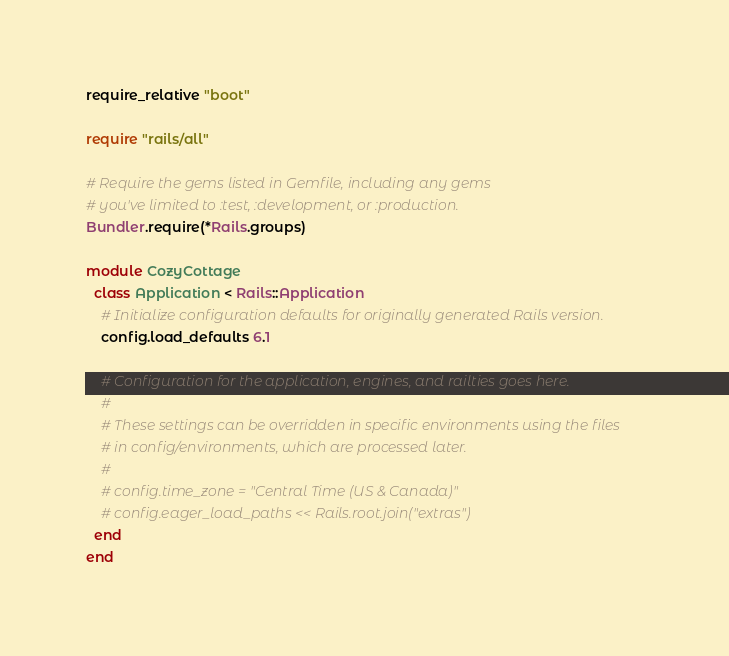Convert code to text. <code><loc_0><loc_0><loc_500><loc_500><_Ruby_>require_relative "boot"

require "rails/all"

# Require the gems listed in Gemfile, including any gems
# you've limited to :test, :development, or :production.
Bundler.require(*Rails.groups)

module CozyCottage
  class Application < Rails::Application
    # Initialize configuration defaults for originally generated Rails version.
    config.load_defaults 6.1

    # Configuration for the application, engines, and railties goes here.
    #
    # These settings can be overridden in specific environments using the files
    # in config/environments, which are processed later.
    #
    # config.time_zone = "Central Time (US & Canada)"
    # config.eager_load_paths << Rails.root.join("extras")
  end
end
</code> 